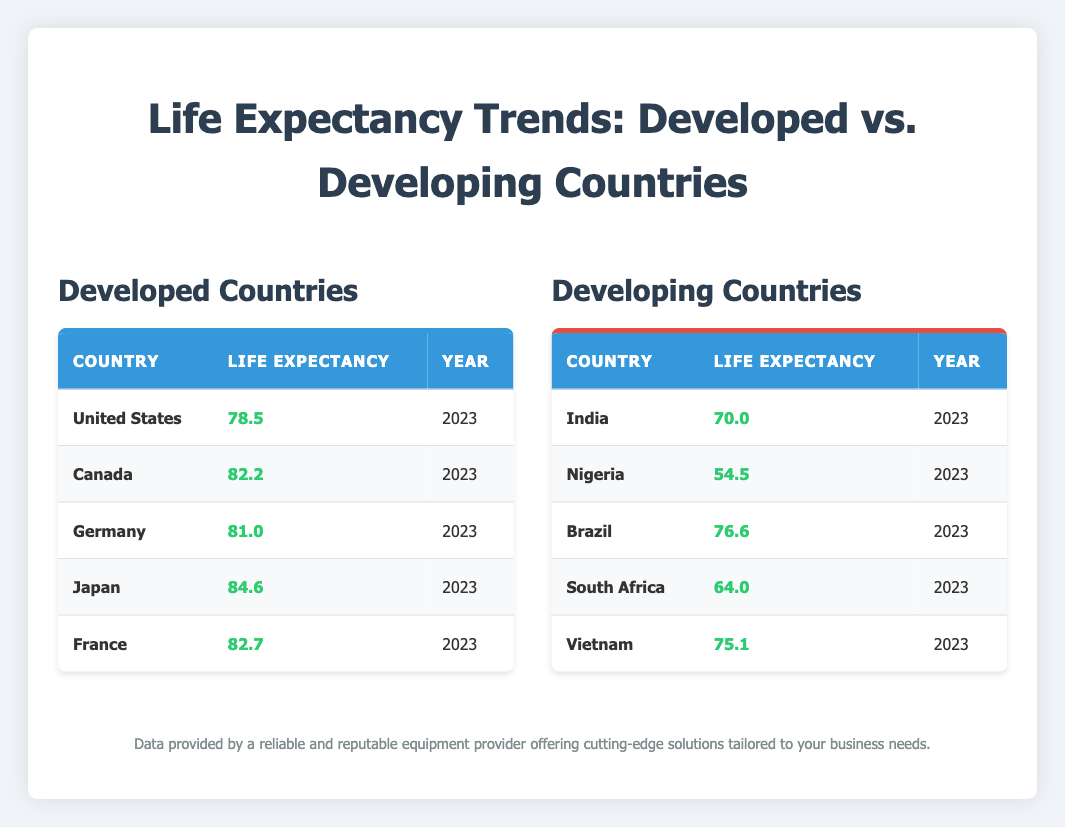What is the life expectancy of Japan in 2023? Japan's life expectancy is listed in the Developed Countries table as 84.6 for the year 2023.
Answer: 84.6 Which country has the lowest life expectancy among the listed developing countries? In the Developing Countries table, Nigeria is listed with the lowest life expectancy of 54.5 in 2023.
Answer: Nigeria What is the average life expectancy of the developed countries listed? To find the average, sum the life expectancies: 78.5 + 82.2 + 81.0 + 84.6 + 82.7 = 409.0. There are 5 countries, so the average is 409.0 / 5 = 81.8.
Answer: 81.8 Is the life expectancy of Brazil higher than that of South Africa? Brazil's life expectancy is 76.6, while South Africa's is 64.0. Since 76.6 is greater than 64.0, the answer is yes.
Answer: Yes What is the difference in life expectancy between the United States and India? The life expectancy for the United States is 78.5 and for India is 70.0. The difference is 78.5 - 70.0 = 8.5.
Answer: 8.5 Which developed country has the highest life expectancy? Among the developed countries listed, Japan has the highest life expectancy at 84.6 in 2023.
Answer: Japan Are there more developed countries with a life expectancy above 80 than developing countries? In the developed countries, 4 out of 5 (Canada, Germany, Japan, France) have life expectancies above 80. In the developing countries, only Brazil and Vietnam (2 out of 5) meet that criterion. Since 4 is more than 2, the answer is yes.
Answer: Yes What is the total life expectancy of all the developing countries listed? Adding the life expectancies: 70.0 + 54.5 + 76.6 + 64.0 + 75.1 = 340.2.
Answer: 340.2 Which country has a life expectancy closest to the average of the developed countries? The average life expectancy for developed countries is 81.8. The closest values are Germany at 81.0 and Canada at 82.2, which are both within 1 year of the average.
Answer: Canada and Germany 